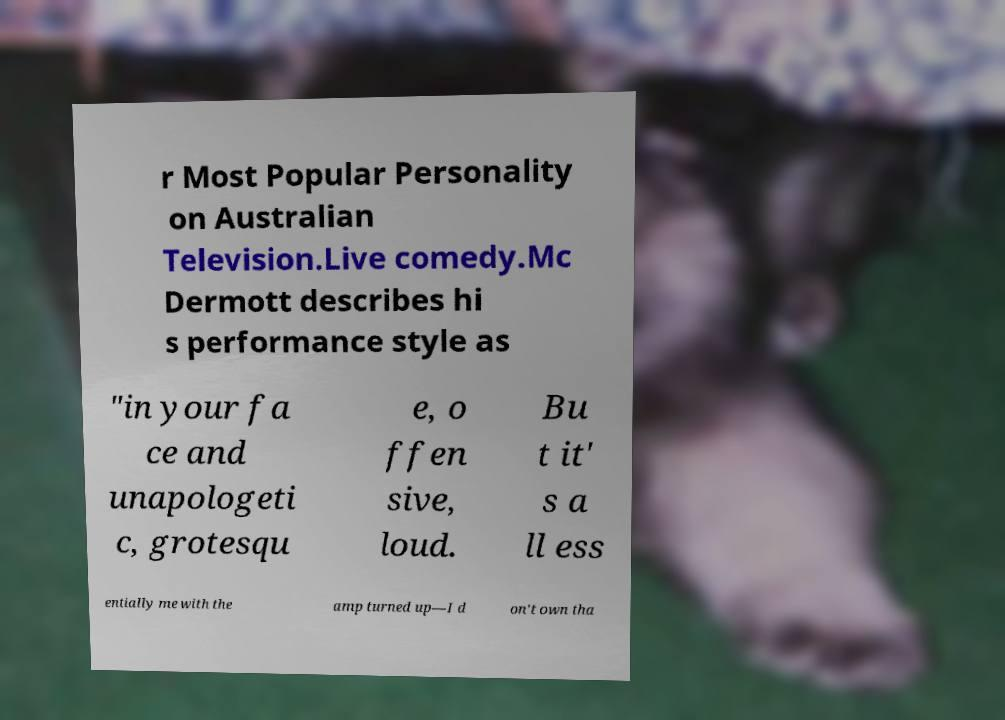Can you read and provide the text displayed in the image?This photo seems to have some interesting text. Can you extract and type it out for me? r Most Popular Personality on Australian Television.Live comedy.Mc Dermott describes hi s performance style as "in your fa ce and unapologeti c, grotesqu e, o ffen sive, loud. Bu t it' s a ll ess entially me with the amp turned up—I d on't own tha 